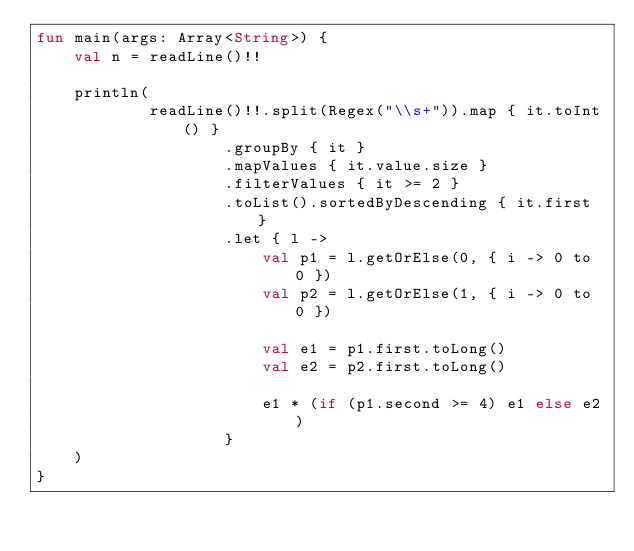<code> <loc_0><loc_0><loc_500><loc_500><_Kotlin_>fun main(args: Array<String>) {
    val n = readLine()!!

    println(
            readLine()!!.split(Regex("\\s+")).map { it.toInt() }
                    .groupBy { it }
                    .mapValues { it.value.size }
                    .filterValues { it >= 2 }
                    .toList().sortedByDescending { it.first }
                    .let { l ->
                        val p1 = l.getOrElse(0, { i -> 0 to 0 })
                        val p2 = l.getOrElse(1, { i -> 0 to 0 })

                        val e1 = p1.first.toLong()
                        val e2 = p2.first.toLong()
                        
                        e1 * (if (p1.second >= 4) e1 else e2)
                    }
    )
}
</code> 